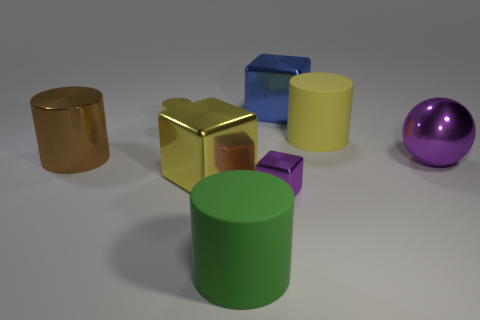Subtract 1 cylinders. How many cylinders are left? 3 Add 2 purple cubes. How many objects exist? 10 Subtract all cubes. How many objects are left? 5 Add 5 blue objects. How many blue objects are left? 6 Add 1 large brown things. How many large brown things exist? 2 Subtract 0 red blocks. How many objects are left? 8 Subtract all big green cylinders. Subtract all brown things. How many objects are left? 6 